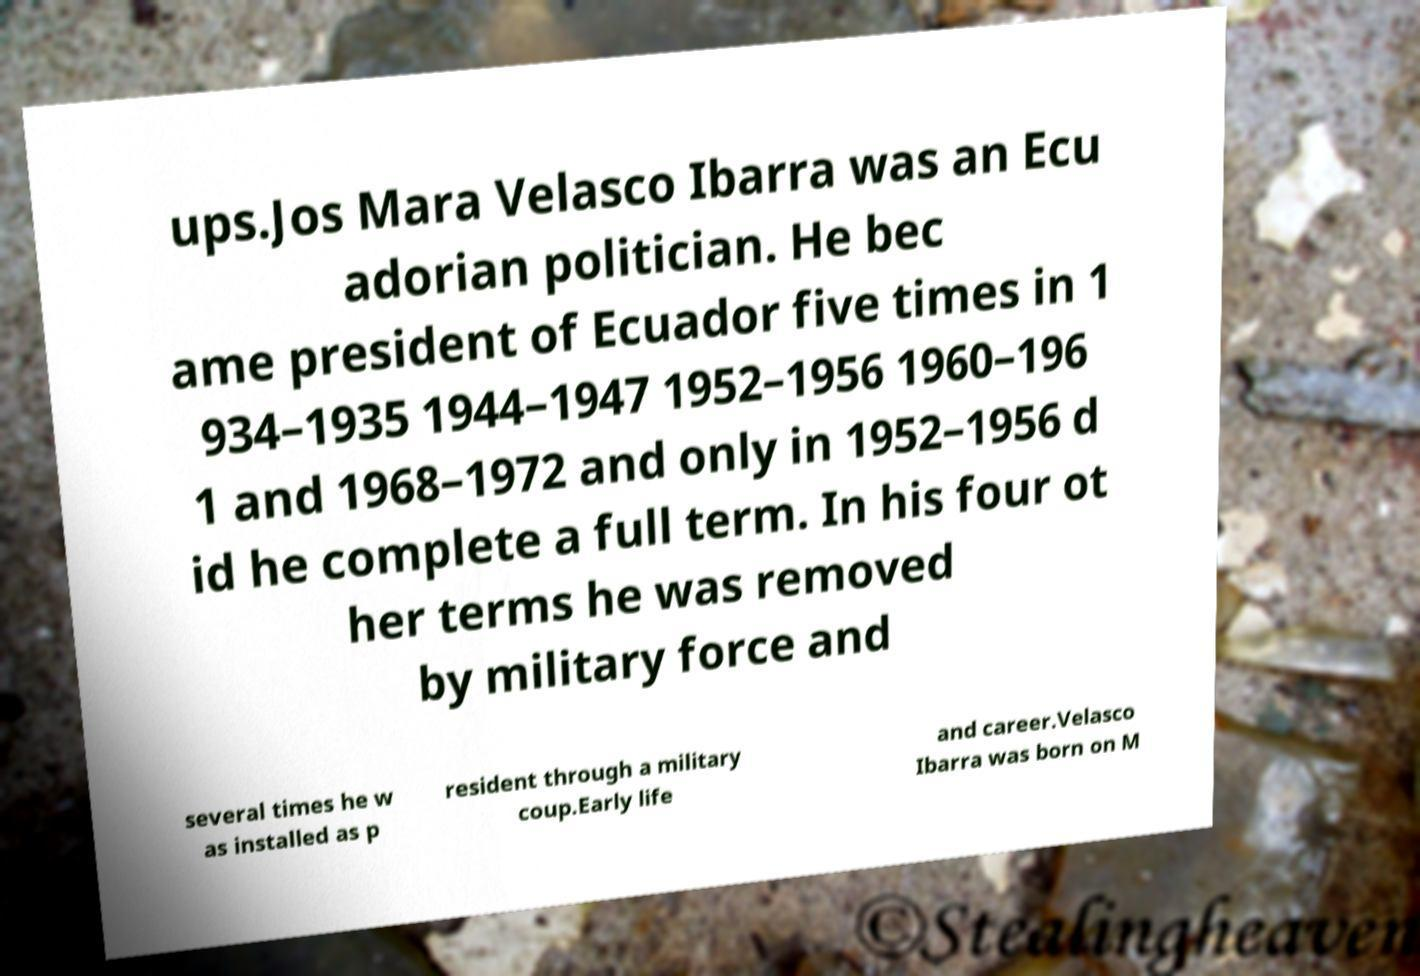What messages or text are displayed in this image? I need them in a readable, typed format. ups.Jos Mara Velasco Ibarra was an Ecu adorian politician. He bec ame president of Ecuador five times in 1 934–1935 1944–1947 1952–1956 1960–196 1 and 1968–1972 and only in 1952–1956 d id he complete a full term. In his four ot her terms he was removed by military force and several times he w as installed as p resident through a military coup.Early life and career.Velasco Ibarra was born on M 